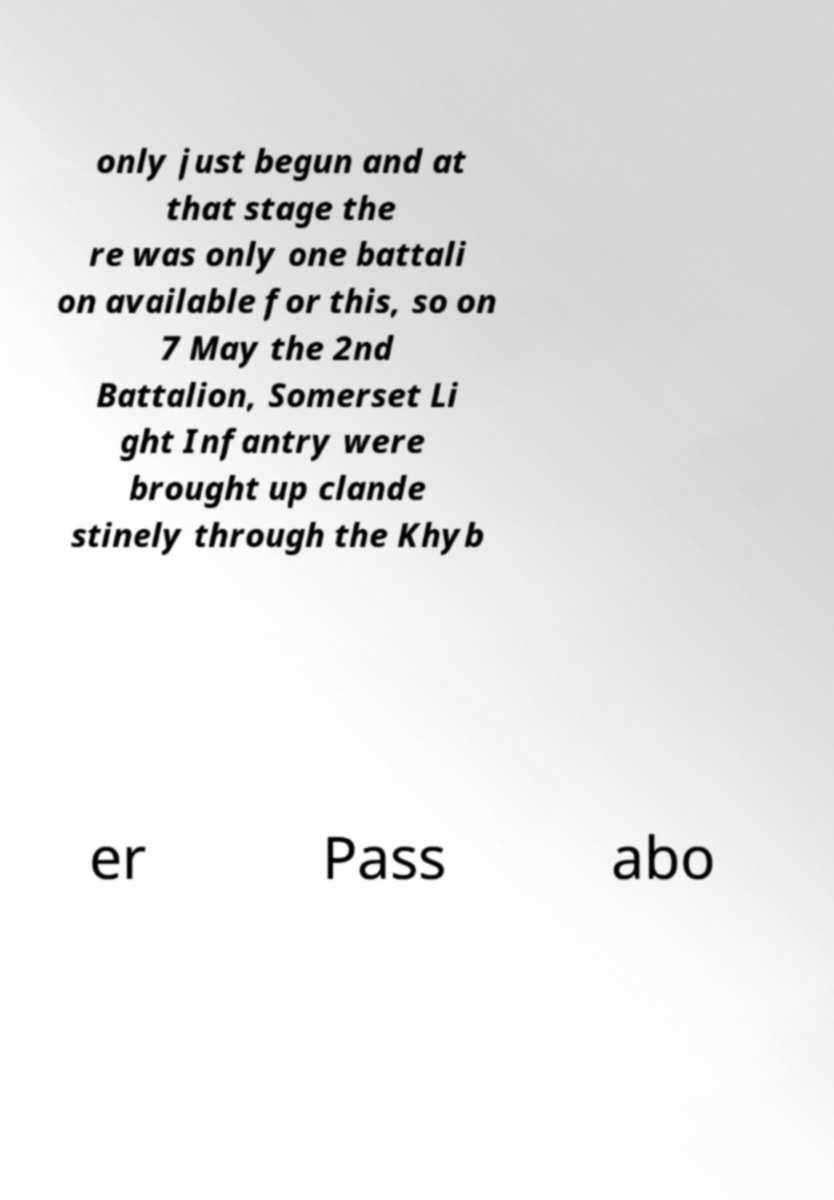What messages or text are displayed in this image? I need them in a readable, typed format. only just begun and at that stage the re was only one battali on available for this, so on 7 May the 2nd Battalion, Somerset Li ght Infantry were brought up clande stinely through the Khyb er Pass abo 